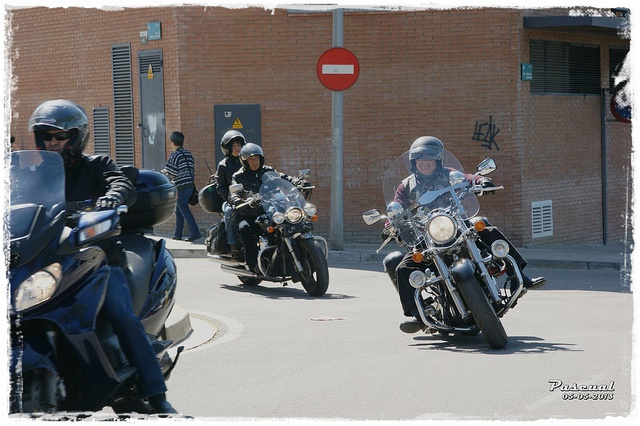Describe the objects in this image and their specific colors. I can see motorcycle in white, black, navy, gray, and blue tones, motorcycle in white, gray, black, and darkgray tones, people in white, black, navy, gray, and blue tones, people in white, gray, black, darkgray, and blue tones, and motorcycle in white, black, gray, darkgray, and blue tones in this image. 